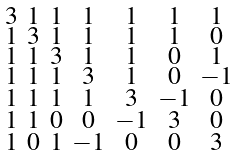Convert formula to latex. <formula><loc_0><loc_0><loc_500><loc_500>\begin{smallmatrix} 3 & 1 & 1 & 1 & 1 & 1 & 1 \\ 1 & 3 & 1 & 1 & 1 & 1 & 0 \\ 1 & 1 & 3 & 1 & 1 & 0 & 1 \\ 1 & 1 & 1 & 3 & 1 & 0 & - 1 \\ 1 & 1 & 1 & 1 & 3 & - 1 & 0 \\ 1 & 1 & 0 & 0 & - 1 & 3 & 0 \\ 1 & 0 & 1 & - 1 & 0 & 0 & 3 \end{smallmatrix}</formula> 